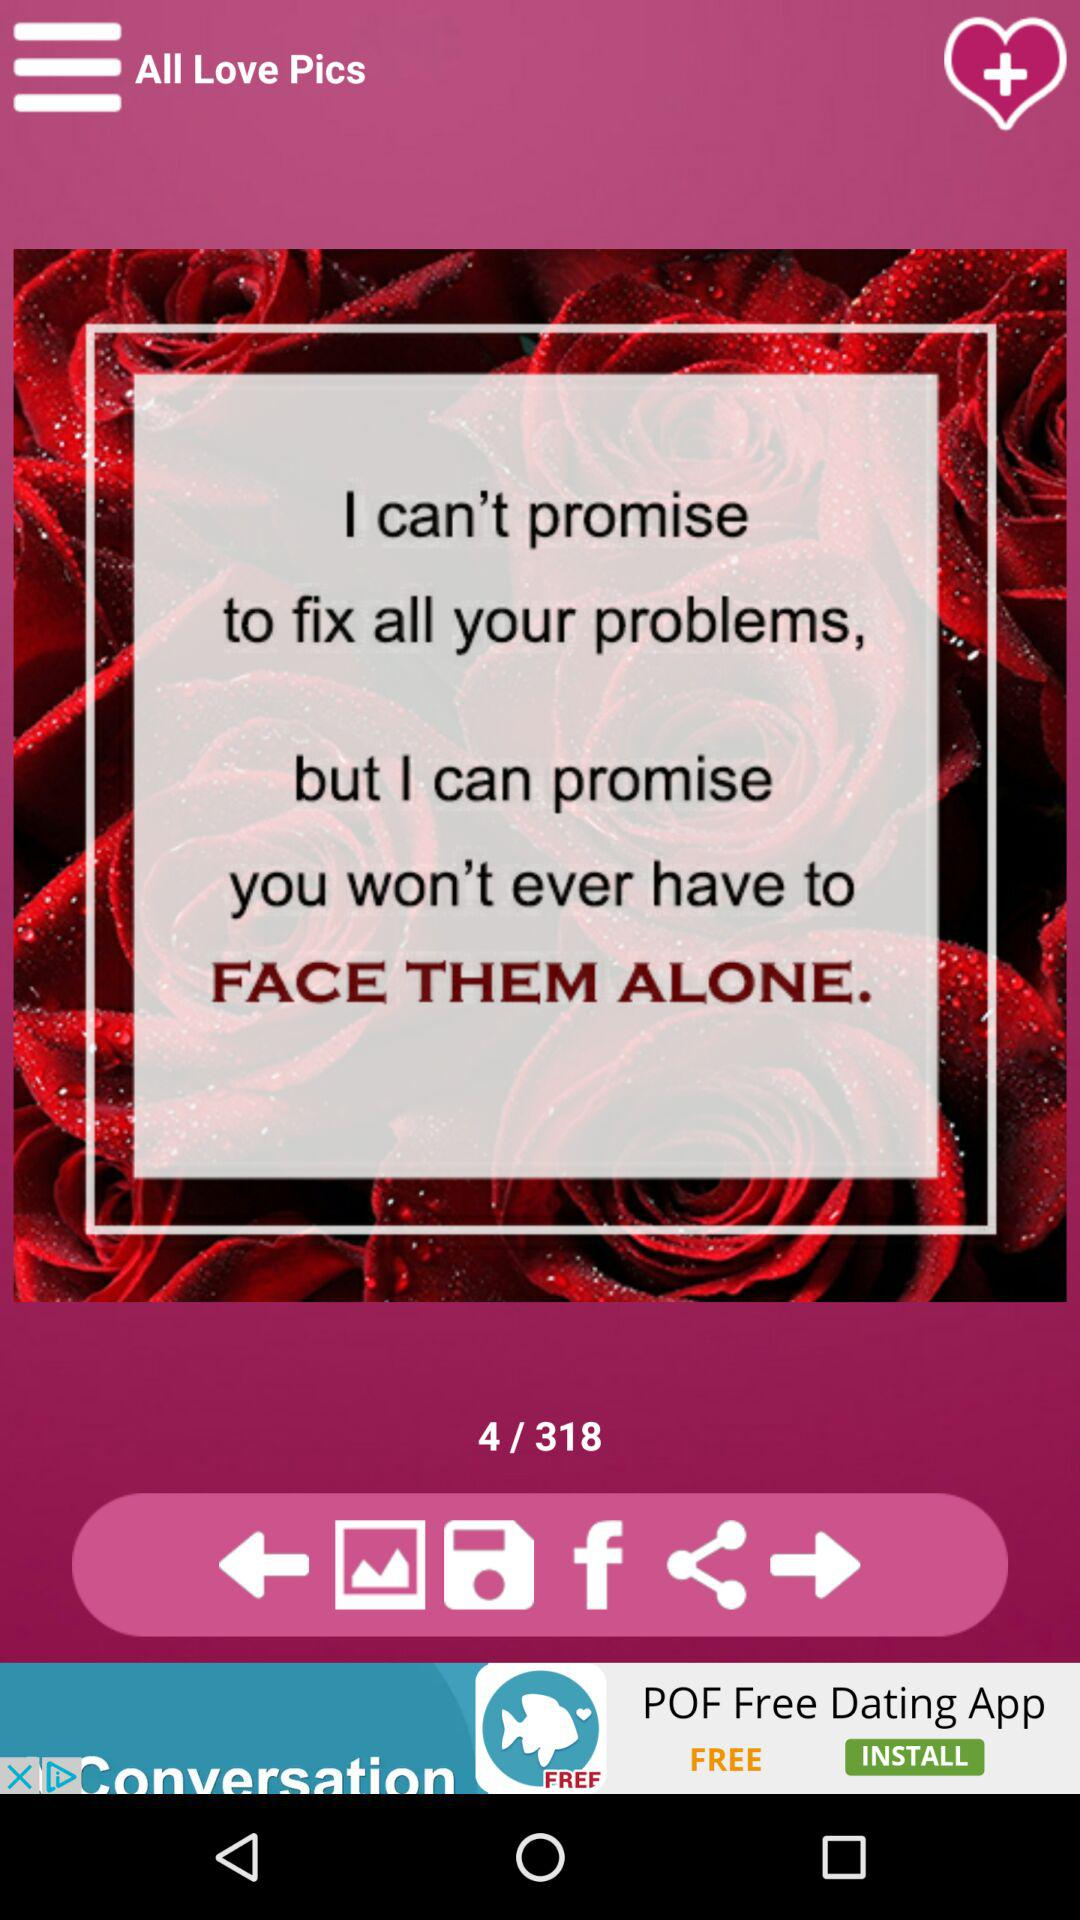How many slides are there in total? There are 318 total slides. 